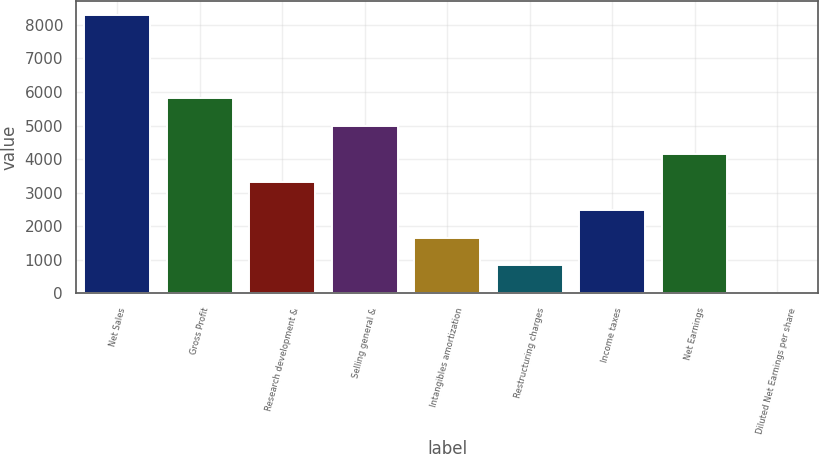Convert chart to OTSL. <chart><loc_0><loc_0><loc_500><loc_500><bar_chart><fcel>Net Sales<fcel>Gross Profit<fcel>Research development &<fcel>Selling general &<fcel>Intangibles amortization<fcel>Restructuring charges<fcel>Income taxes<fcel>Net Earnings<fcel>Diluted Net Earnings per share<nl><fcel>8307<fcel>5815.94<fcel>3324.88<fcel>4985.59<fcel>1664.16<fcel>833.81<fcel>2494.52<fcel>4155.24<fcel>3.45<nl></chart> 